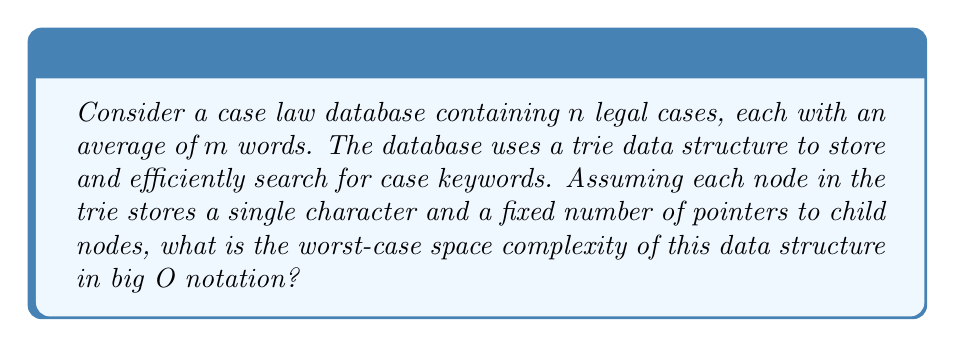Help me with this question. To determine the space complexity, let's analyze the trie structure:

1. Each case has an average of $m$ words.
2. Let's assume an average word length of $k$ characters.
3. The total number of characters in the database is approximately $n \cdot m \cdot k$.

In a trie:
- Each character is stored in a separate node.
- Each node contains:
  a. A character (constant space)
  b. Pointers to child nodes (constant space, as the alphabet size is fixed)

Worst-case scenario:
- All words are unique and have no common prefixes.
- The trie would have a separate branch for each word.

Space required:
1. Number of nodes: $O(n \cdot m \cdot k)$
2. Space per node: $O(1)$

Therefore, the total space complexity is:

$$ O(n \cdot m \cdot k \cdot 1) = O(nmk) $$

This represents the worst-case scenario where the trie stores all characters of all words without any shared prefixes.
Answer: $O(nmk)$, where $n$ is the number of cases, $m$ is the average number of words per case, and $k$ is the average word length. 